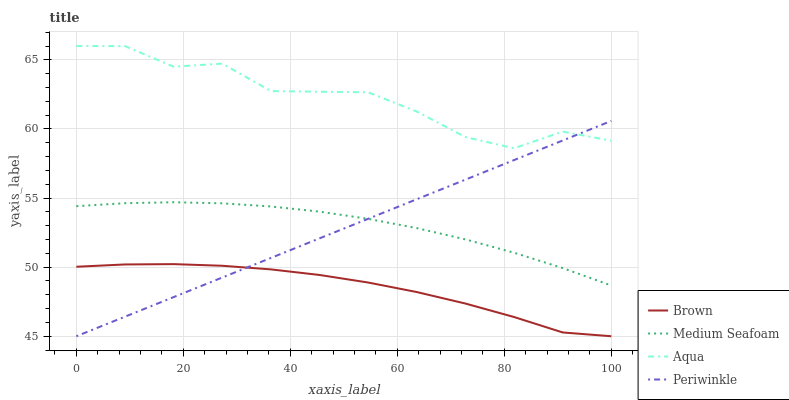Does Periwinkle have the minimum area under the curve?
Answer yes or no. No. Does Periwinkle have the maximum area under the curve?
Answer yes or no. No. Is Aqua the smoothest?
Answer yes or no. No. Is Periwinkle the roughest?
Answer yes or no. No. Does Aqua have the lowest value?
Answer yes or no. No. Does Periwinkle have the highest value?
Answer yes or no. No. Is Medium Seafoam less than Aqua?
Answer yes or no. Yes. Is Aqua greater than Brown?
Answer yes or no. Yes. Does Medium Seafoam intersect Aqua?
Answer yes or no. No. 